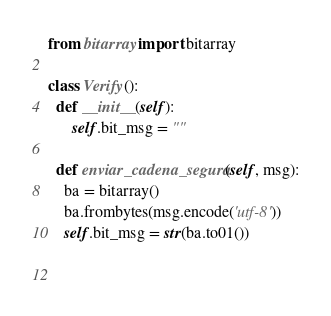Convert code to text. <code><loc_0><loc_0><loc_500><loc_500><_Python_>from bitarray import bitarray

class Verify():
  def __init__(self):
      self.bit_msg = ""

  def enviar_cadena_segura(self, msg):
    ba = bitarray()
    ba.frombytes(msg.encode('utf-8'))
    self.bit_msg = str(ba.to01())
   
    </code> 